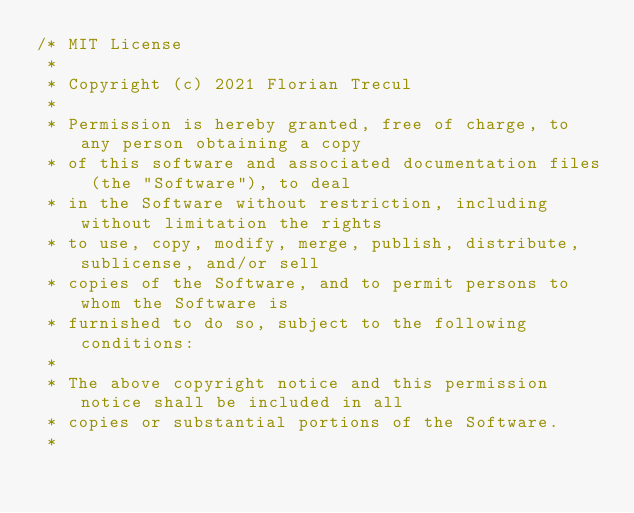Convert code to text. <code><loc_0><loc_0><loc_500><loc_500><_Kotlin_>/* MIT License
 *
 * Copyright (c) 2021 Florian Trecul
 *
 * Permission is hereby granted, free of charge, to any person obtaining a copy
 * of this software and associated documentation files (the "Software"), to deal
 * in the Software without restriction, including without limitation the rights
 * to use, copy, modify, merge, publish, distribute, sublicense, and/or sell
 * copies of the Software, and to permit persons to whom the Software is
 * furnished to do so, subject to the following conditions:
 *
 * The above copyright notice and this permission notice shall be included in all
 * copies or substantial portions of the Software.
 *</code> 